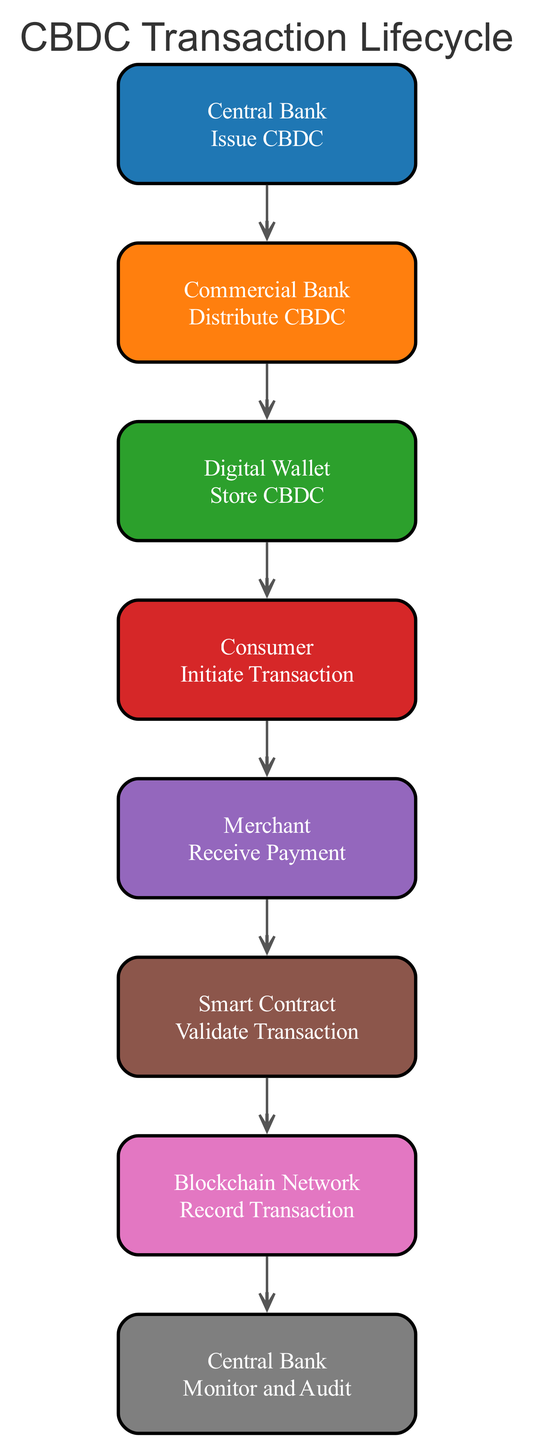What entity issues the CBDC? According to the diagram, the first entity is the Central Bank, which is responsible for issuing the CBDC.
Answer: Central Bank How many nodes are in the diagram? Counting the steps listed in the diagram, there are eight distinct entities represented, which corresponds to eight nodes.
Answer: 8 What action does a consumer take? The consumer initiates a transaction, as indicated in the actions outlined in the diagram.
Answer: Initiate Transaction What function does the Smart Contract serve in the transaction lifecycle? The diagram states that the Smart Contract validates the transaction to ensure its compliance and validity.
Answer: Validate Transaction What does the Blockchain Network do after a transaction is validated? Following validation, the Blockchain Network records the transaction, ensuring it is preserved in the ledger.
Answer: Record Transaction Which entity is responsible for overseeing and auditing the transactions? The Central Bank is assigned the role of monitoring and auditing transaction data in the lifecycle process.
Answer: Central Bank How are payments acknowledged in the transaction? The Merchant's action of receiving CBDC in their digital wallet signifies the acknowledgment of payment from the consumer.
Answer: Receive Payment What initiates the transaction process? The transaction process is initiated by the Consumer using their digital wallet to send CBDC.
Answer: Digital Wallet How does the Central Bank ensure the integrity of the CBDC ecosystem? The Central Bank ensures integrity through monitoring and auditing transaction data, maintaining security throughout the ecosystem.
Answer: Monitor and Audit 